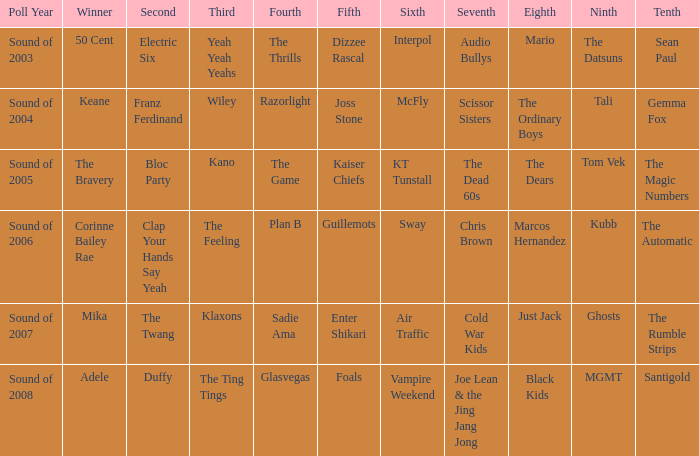Can you give me this table as a dict? {'header': ['Poll Year', 'Winner', 'Second', 'Third', 'Fourth', 'Fifth', 'Sixth', 'Seventh', 'Eighth', 'Ninth', 'Tenth'], 'rows': [['Sound of 2003', '50 Cent', 'Electric Six', 'Yeah Yeah Yeahs', 'The Thrills', 'Dizzee Rascal', 'Interpol', 'Audio Bullys', 'Mario', 'The Datsuns', 'Sean Paul'], ['Sound of 2004', 'Keane', 'Franz Ferdinand', 'Wiley', 'Razorlight', 'Joss Stone', 'McFly', 'Scissor Sisters', 'The Ordinary Boys', 'Tali', 'Gemma Fox'], ['Sound of 2005', 'The Bravery', 'Bloc Party', 'Kano', 'The Game', 'Kaiser Chiefs', 'KT Tunstall', 'The Dead 60s', 'The Dears', 'Tom Vek', 'The Magic Numbers'], ['Sound of 2006', 'Corinne Bailey Rae', 'Clap Your Hands Say Yeah', 'The Feeling', 'Plan B', 'Guillemots', 'Sway', 'Chris Brown', 'Marcos Hernandez', 'Kubb', 'The Automatic'], ['Sound of 2007', 'Mika', 'The Twang', 'Klaxons', 'Sadie Ama', 'Enter Shikari', 'Air Traffic', 'Cold War Kids', 'Just Jack', 'Ghosts', 'The Rumble Strips'], ['Sound of 2008', 'Adele', 'Duffy', 'The Ting Tings', 'Glasvegas', 'Foals', 'Vampire Weekend', 'Joe Lean & the Jing Jang Jong', 'Black Kids', 'MGMT', 'Santigold']]} When Interpol is in 6th, who is in 7th? 1.0. 